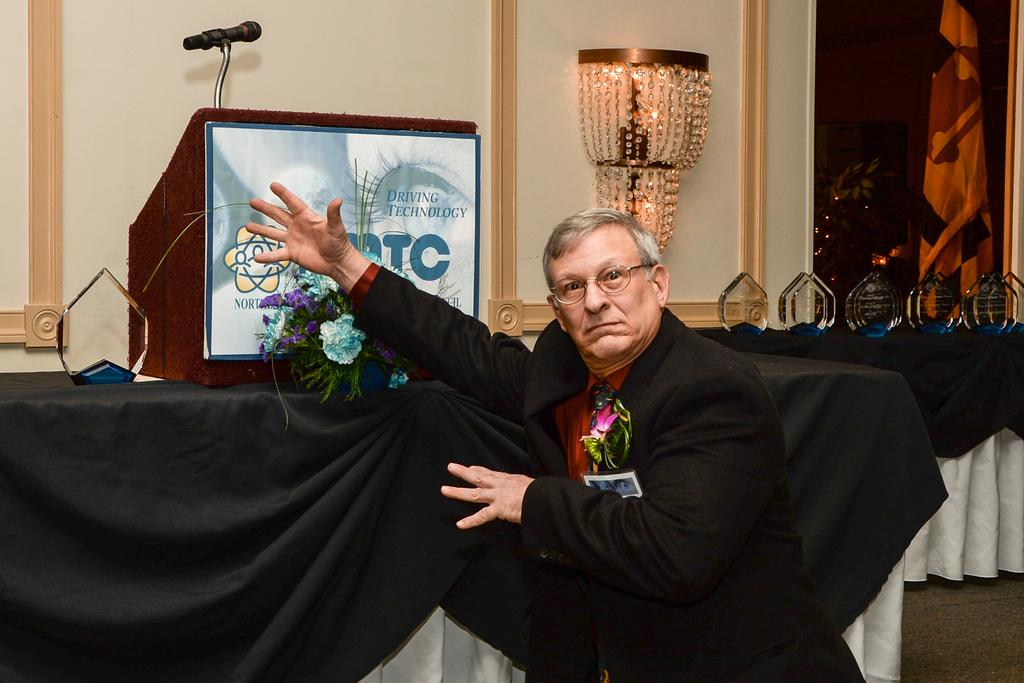What is the main subject of the image? There is a man in the image. What is the man wearing? The man is wearing a black coat and specs. What objects can be seen in the image related to a presentation or speech? There is a podium and a microphone in the image. What color is the cloth visible in the image? There is a black colored cloth in the image. What architectural features can be seen in the background of the image? There is a window and a wall in the image. What type of wood can be seen in the image? There is no wood visible in the image. What is the man pointing at with a whip in the image? There is no whip present in the image, and the man is not pointing at anything. 